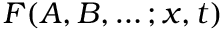Convert formula to latex. <formula><loc_0><loc_0><loc_500><loc_500>F ( A , B , \dots ; x , t )</formula> 